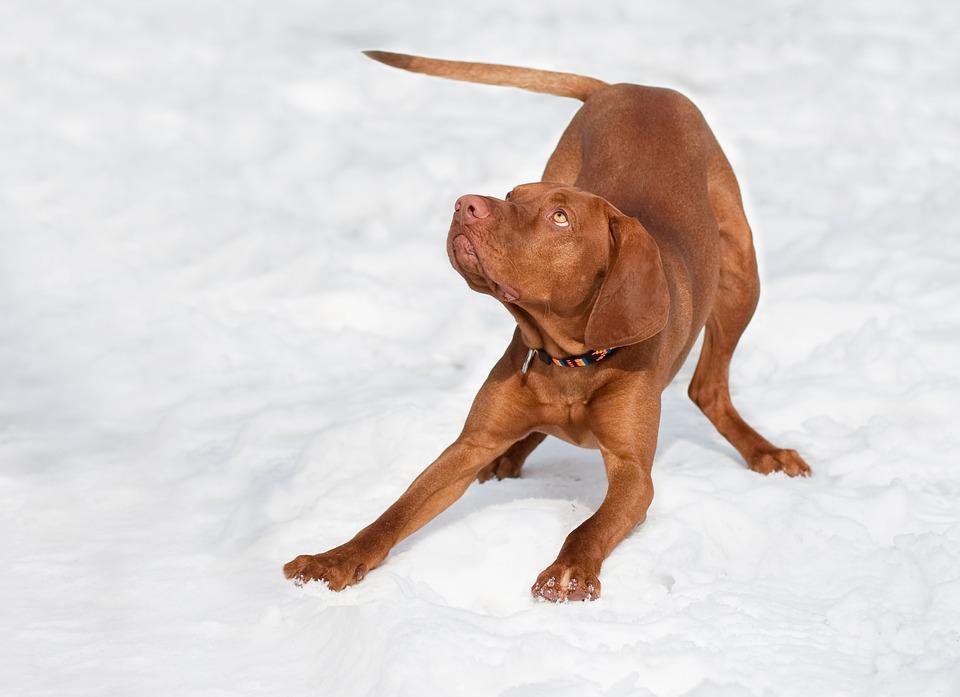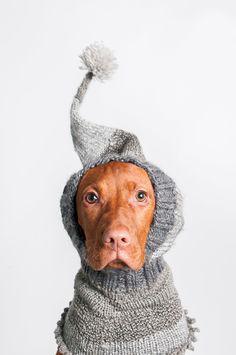The first image is the image on the left, the second image is the image on the right. Given the left and right images, does the statement "The right image contains a brown dog that is wearing clothing on their head." hold true? Answer yes or no. Yes. The first image is the image on the left, the second image is the image on the right. Examine the images to the left and right. Is the description "A dog is wearing a knit hat." accurate? Answer yes or no. Yes. 